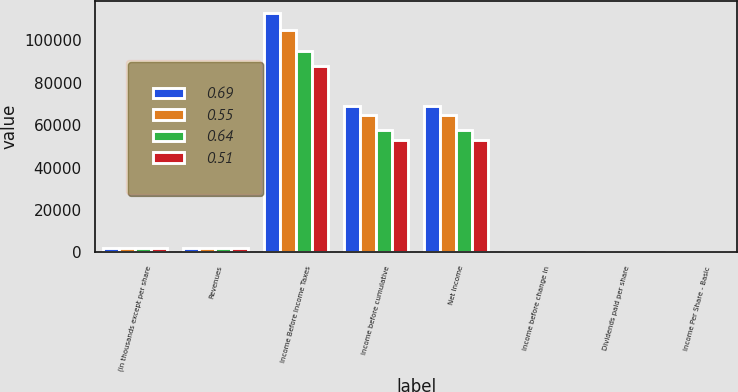<chart> <loc_0><loc_0><loc_500><loc_500><stacked_bar_chart><ecel><fcel>(in thousands except per share<fcel>Revenues<fcel>Income Before Income Taxes<fcel>Income before cumulative<fcel>Net Income<fcel>Income before change in<fcel>Dividends paid per share<fcel>Income Per Share - Basic<nl><fcel>0.69<fcel>2008<fcel>2006.5<fcel>112954<fcel>68934<fcel>68934<fcel>0.69<fcel>0.25<fcel>0.69<nl><fcel>0.55<fcel>2007<fcel>2006.5<fcel>104913<fcel>64731<fcel>64731<fcel>0.65<fcel>0.2<fcel>0.65<nl><fcel>0.64<fcel>2006<fcel>2006.5<fcel>95159<fcel>57809<fcel>57809<fcel>0.57<fcel>0.17<fcel>0.57<nl><fcel>0.51<fcel>2005<fcel>2006.5<fcel>87955<fcel>52773<fcel>52773<fcel>0.52<fcel>0.13<fcel>0.52<nl></chart> 